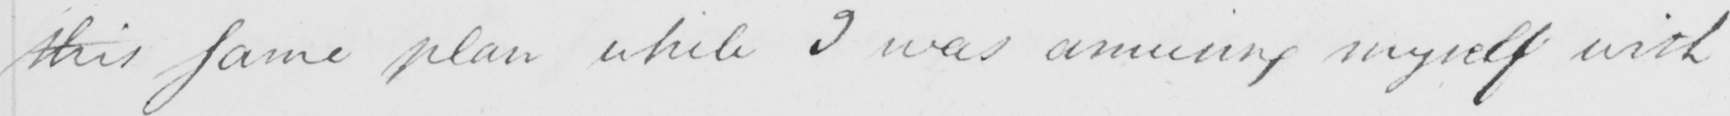Can you read and transcribe this handwriting? this same plan while I was amusing myself with 